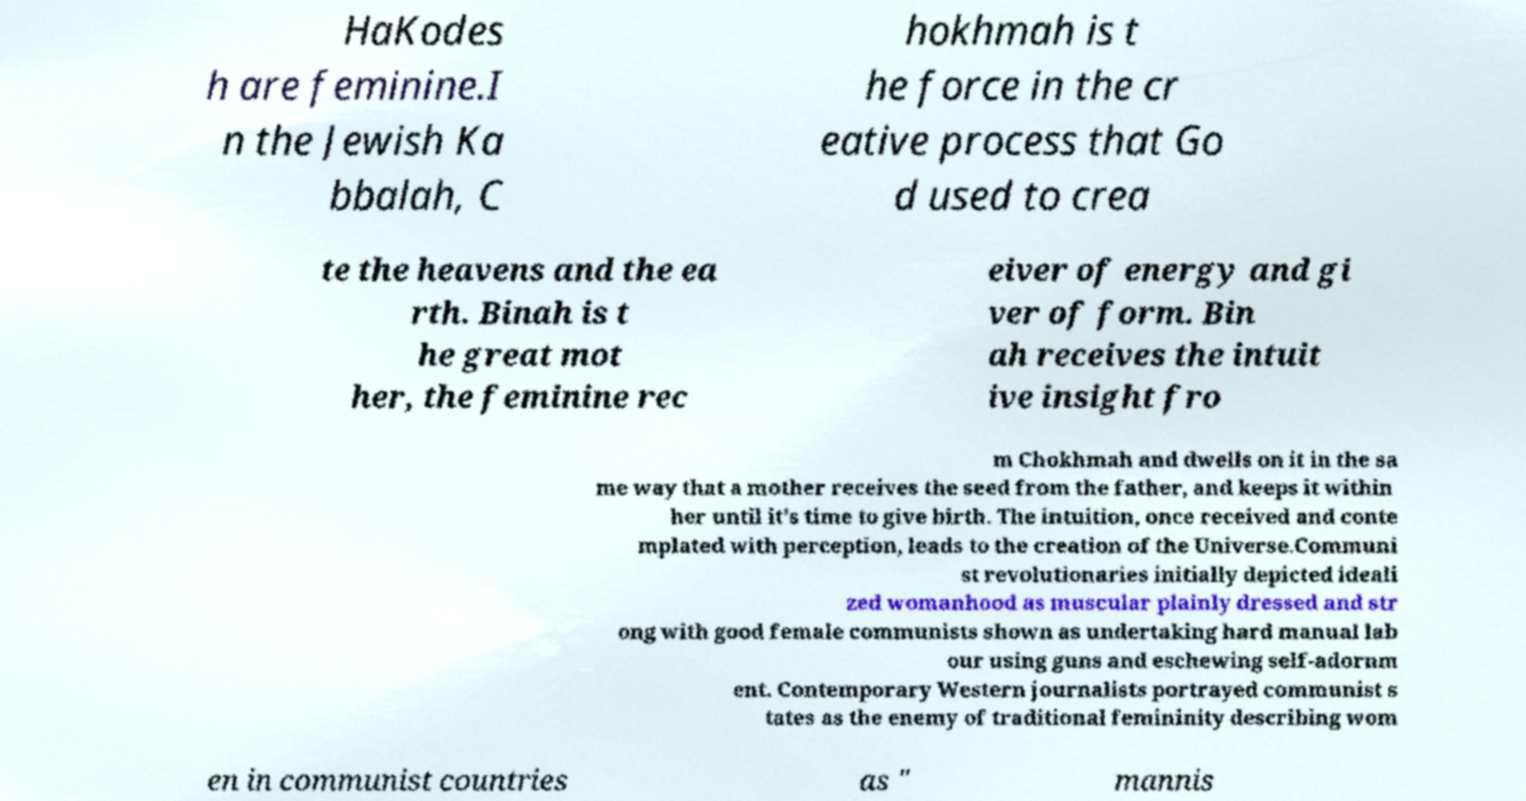I need the written content from this picture converted into text. Can you do that? HaKodes h are feminine.I n the Jewish Ka bbalah, C hokhmah is t he force in the cr eative process that Go d used to crea te the heavens and the ea rth. Binah is t he great mot her, the feminine rec eiver of energy and gi ver of form. Bin ah receives the intuit ive insight fro m Chokhmah and dwells on it in the sa me way that a mother receives the seed from the father, and keeps it within her until it's time to give birth. The intuition, once received and conte mplated with perception, leads to the creation of the Universe.Communi st revolutionaries initially depicted ideali zed womanhood as muscular plainly dressed and str ong with good female communists shown as undertaking hard manual lab our using guns and eschewing self-adornm ent. Contemporary Western journalists portrayed communist s tates as the enemy of traditional femininity describing wom en in communist countries as " mannis 